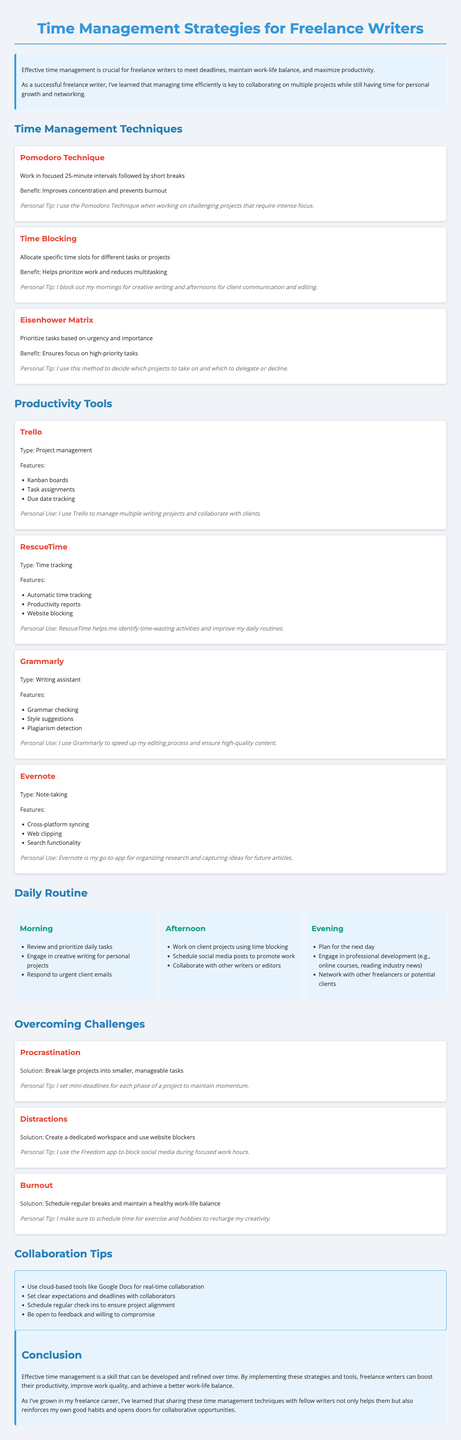What is the first time management technique mentioned? The first time management technique listed in the document is the Pomodoro Technique.
Answer: Pomodoro Technique How long are the focused intervals in the Pomodoro Technique? The Pomodoro Technique involves working in focused intervals of 25 minutes.
Answer: 25 minutes Which productivity tool helps with grammar checking? Grammarly is specifically mentioned as a tool that assists with grammar checking.
Answer: Grammarly What is one personal tip given for using the Eisenhower Matrix? The personal tip for using the Eisenhower Matrix emphasizes deciding which projects to take on and which to delegate or decline.
Answer: Decide which projects to take on and which to delegate or decline What challenge does the document suggest breaking projects into smaller tasks for? The document recommends breaking large projects into smaller tasks specifically to overcome procrastination.
Answer: Procrastination What is one method for overcoming distractions mentioned in the report? The report suggests creating a dedicated workspace and using website blockers to combat distractions.
Answer: Create a dedicated workspace and use website blockers How often should one schedule breaks to avoid burnout? The document emphasizes the importance of scheduling regular breaks to help avoid burnout.
Answer: Regular breaks What is a key takeaway from the conclusion? A key takeaway from the report is that effective time management is a skill that can be developed and refined over time.
Answer: Effective time management is a skill that can be developed and refined 